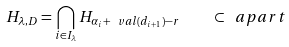Convert formula to latex. <formula><loc_0><loc_0><loc_500><loc_500>H _ { \lambda , D } = \bigcap _ { i \in I _ { \lambda } } H _ { \alpha _ { i } + \ v a l ( d _ { i + 1 } ) - r } \quad \subset \ a p a r t</formula> 